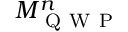<formula> <loc_0><loc_0><loc_500><loc_500>M _ { Q W P } ^ { n }</formula> 